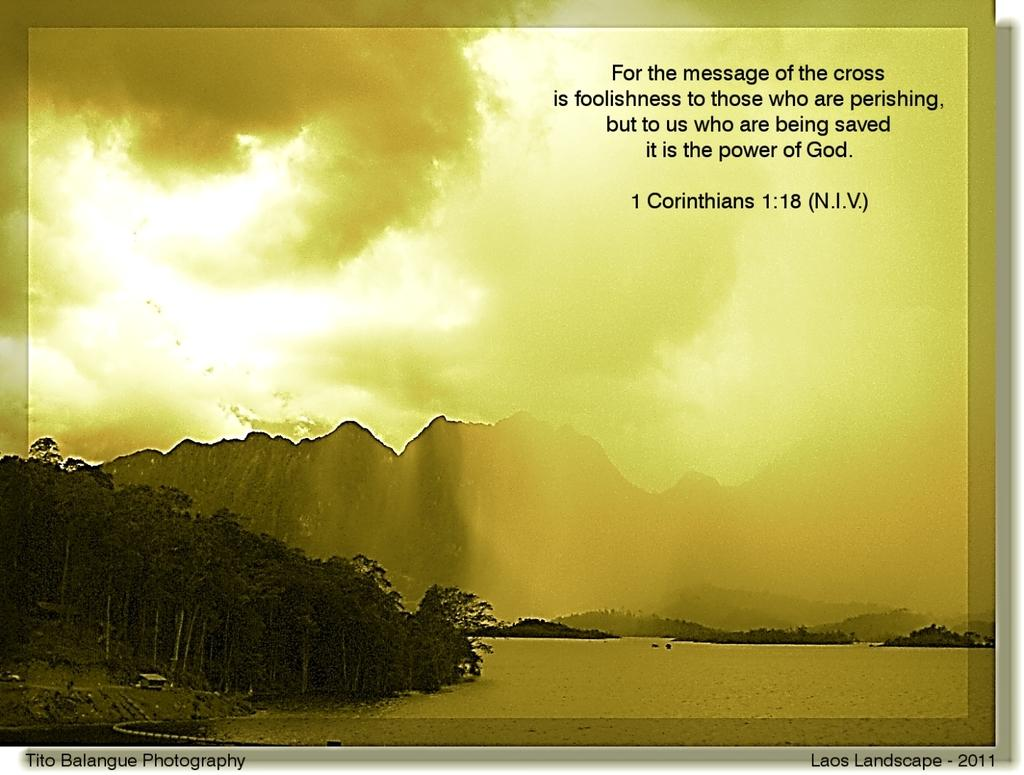<image>
Provide a brief description of the given image. A quote is shown from the bible, specifically 1 Corinthians 1:18. 